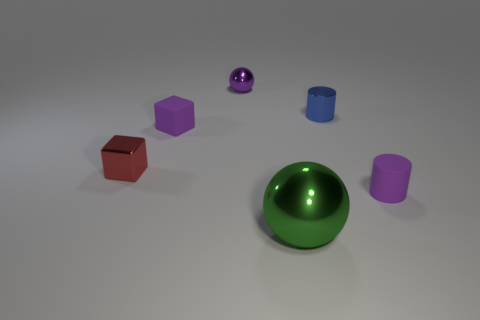Add 1 purple matte cylinders. How many objects exist? 7 Subtract all purple blocks. How many blocks are left? 1 Subtract all cubes. How many objects are left? 4 Subtract 1 cubes. How many cubes are left? 1 Subtract all brown cylinders. Subtract all green cubes. How many cylinders are left? 2 Subtract all yellow spheres. How many red blocks are left? 1 Subtract all large cyan cylinders. Subtract all tiny purple matte objects. How many objects are left? 4 Add 4 small purple matte objects. How many small purple matte objects are left? 6 Add 1 small blue matte things. How many small blue matte things exist? 1 Subtract 0 blue blocks. How many objects are left? 6 